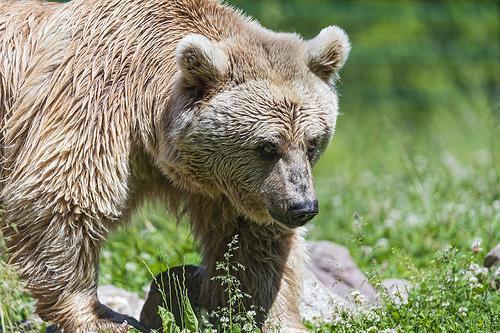How many bears are there?
Give a very brief answer. 1. 